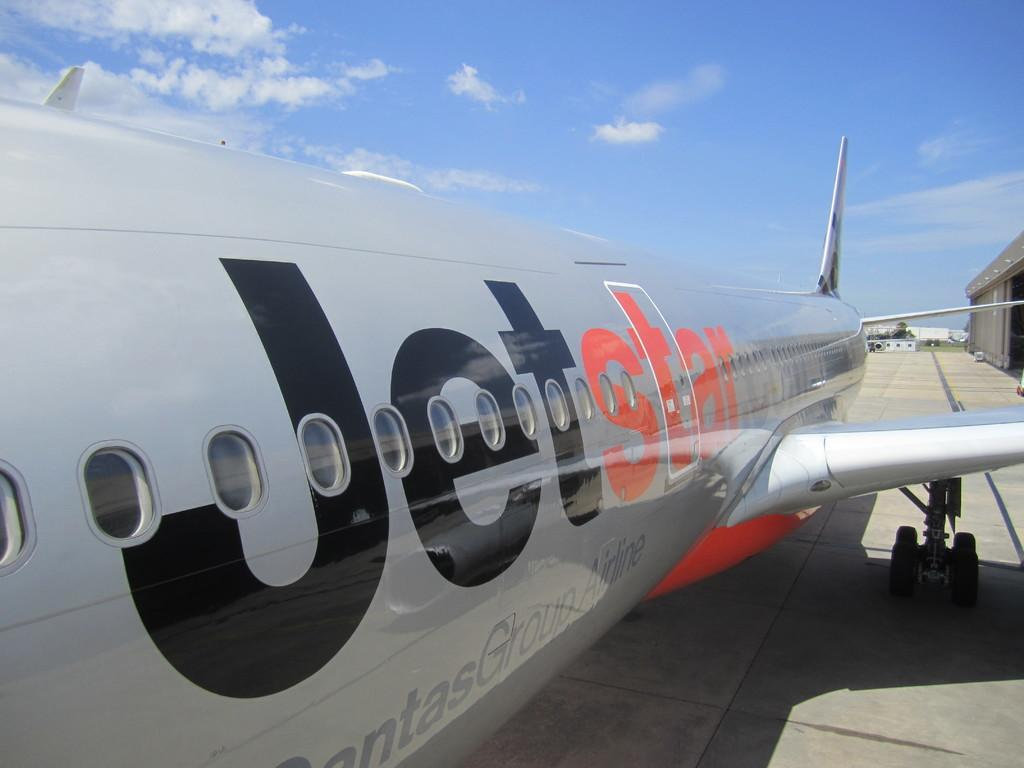<image>
Offer a succinct explanation of the picture presented. The Jetstar plane is on the runway on a sunny day. 